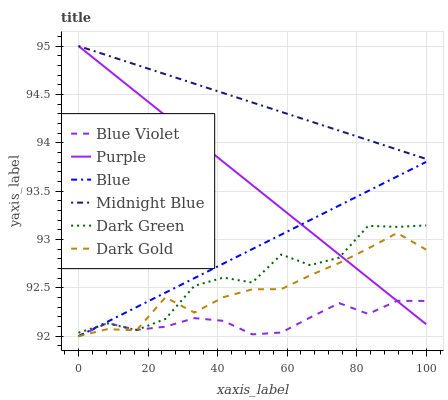Does Blue Violet have the minimum area under the curve?
Answer yes or no. Yes. Does Midnight Blue have the maximum area under the curve?
Answer yes or no. Yes. Does Dark Gold have the minimum area under the curve?
Answer yes or no. No. Does Dark Gold have the maximum area under the curve?
Answer yes or no. No. Is Midnight Blue the smoothest?
Answer yes or no. Yes. Is Dark Green the roughest?
Answer yes or no. Yes. Is Dark Gold the smoothest?
Answer yes or no. No. Is Dark Gold the roughest?
Answer yes or no. No. Does Blue have the lowest value?
Answer yes or no. Yes. Does Midnight Blue have the lowest value?
Answer yes or no. No. Does Purple have the highest value?
Answer yes or no. Yes. Does Dark Gold have the highest value?
Answer yes or no. No. Is Blue Violet less than Midnight Blue?
Answer yes or no. Yes. Is Midnight Blue greater than Blue?
Answer yes or no. Yes. Does Dark Gold intersect Blue?
Answer yes or no. Yes. Is Dark Gold less than Blue?
Answer yes or no. No. Is Dark Gold greater than Blue?
Answer yes or no. No. Does Blue Violet intersect Midnight Blue?
Answer yes or no. No. 